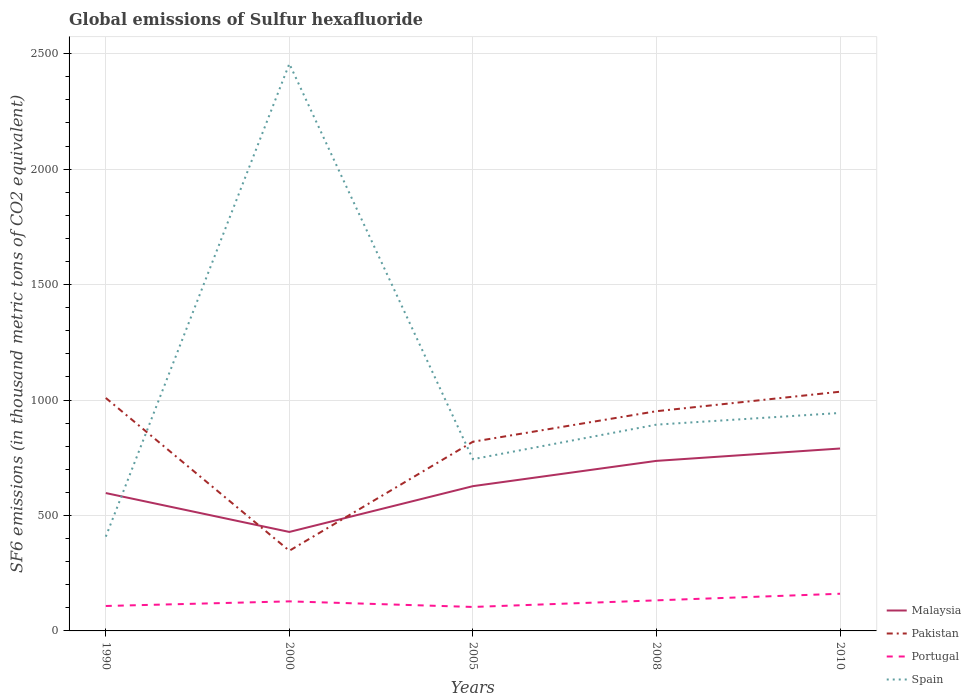How many different coloured lines are there?
Give a very brief answer. 4. Across all years, what is the maximum global emissions of Sulfur hexafluoride in Malaysia?
Your answer should be compact. 428.7. In which year was the global emissions of Sulfur hexafluoride in Spain maximum?
Your response must be concise. 1990. What is the total global emissions of Sulfur hexafluoride in Malaysia in the graph?
Your response must be concise. -139.4. What is the difference between the highest and the second highest global emissions of Sulfur hexafluoride in Portugal?
Keep it short and to the point. 57.2. Is the global emissions of Sulfur hexafluoride in Malaysia strictly greater than the global emissions of Sulfur hexafluoride in Spain over the years?
Provide a short and direct response. No. How many lines are there?
Your response must be concise. 4. How many years are there in the graph?
Make the answer very short. 5. Are the values on the major ticks of Y-axis written in scientific E-notation?
Give a very brief answer. No. Does the graph contain any zero values?
Your answer should be compact. No. How many legend labels are there?
Offer a terse response. 4. What is the title of the graph?
Offer a terse response. Global emissions of Sulfur hexafluoride. What is the label or title of the Y-axis?
Make the answer very short. SF6 emissions (in thousand metric tons of CO2 equivalent). What is the SF6 emissions (in thousand metric tons of CO2 equivalent) of Malaysia in 1990?
Your response must be concise. 597.1. What is the SF6 emissions (in thousand metric tons of CO2 equivalent) in Pakistan in 1990?
Make the answer very short. 1009. What is the SF6 emissions (in thousand metric tons of CO2 equivalent) of Portugal in 1990?
Your answer should be compact. 108. What is the SF6 emissions (in thousand metric tons of CO2 equivalent) in Spain in 1990?
Your answer should be very brief. 408.3. What is the SF6 emissions (in thousand metric tons of CO2 equivalent) in Malaysia in 2000?
Make the answer very short. 428.7. What is the SF6 emissions (in thousand metric tons of CO2 equivalent) in Pakistan in 2000?
Offer a very short reply. 347.2. What is the SF6 emissions (in thousand metric tons of CO2 equivalent) of Portugal in 2000?
Provide a succinct answer. 128. What is the SF6 emissions (in thousand metric tons of CO2 equivalent) in Spain in 2000?
Make the answer very short. 2456.5. What is the SF6 emissions (in thousand metric tons of CO2 equivalent) of Malaysia in 2005?
Make the answer very short. 627. What is the SF6 emissions (in thousand metric tons of CO2 equivalent) of Pakistan in 2005?
Offer a very short reply. 819.4. What is the SF6 emissions (in thousand metric tons of CO2 equivalent) in Portugal in 2005?
Provide a short and direct response. 103.8. What is the SF6 emissions (in thousand metric tons of CO2 equivalent) in Spain in 2005?
Provide a short and direct response. 743.8. What is the SF6 emissions (in thousand metric tons of CO2 equivalent) of Malaysia in 2008?
Ensure brevity in your answer.  736.5. What is the SF6 emissions (in thousand metric tons of CO2 equivalent) in Pakistan in 2008?
Provide a short and direct response. 951.6. What is the SF6 emissions (in thousand metric tons of CO2 equivalent) in Portugal in 2008?
Your answer should be compact. 132.4. What is the SF6 emissions (in thousand metric tons of CO2 equivalent) of Spain in 2008?
Offer a terse response. 893.4. What is the SF6 emissions (in thousand metric tons of CO2 equivalent) in Malaysia in 2010?
Your answer should be very brief. 790. What is the SF6 emissions (in thousand metric tons of CO2 equivalent) in Pakistan in 2010?
Ensure brevity in your answer.  1036. What is the SF6 emissions (in thousand metric tons of CO2 equivalent) in Portugal in 2010?
Ensure brevity in your answer.  161. What is the SF6 emissions (in thousand metric tons of CO2 equivalent) in Spain in 2010?
Your answer should be very brief. 944. Across all years, what is the maximum SF6 emissions (in thousand metric tons of CO2 equivalent) in Malaysia?
Make the answer very short. 790. Across all years, what is the maximum SF6 emissions (in thousand metric tons of CO2 equivalent) of Pakistan?
Give a very brief answer. 1036. Across all years, what is the maximum SF6 emissions (in thousand metric tons of CO2 equivalent) of Portugal?
Your response must be concise. 161. Across all years, what is the maximum SF6 emissions (in thousand metric tons of CO2 equivalent) in Spain?
Ensure brevity in your answer.  2456.5. Across all years, what is the minimum SF6 emissions (in thousand metric tons of CO2 equivalent) in Malaysia?
Offer a terse response. 428.7. Across all years, what is the minimum SF6 emissions (in thousand metric tons of CO2 equivalent) in Pakistan?
Provide a short and direct response. 347.2. Across all years, what is the minimum SF6 emissions (in thousand metric tons of CO2 equivalent) in Portugal?
Give a very brief answer. 103.8. Across all years, what is the minimum SF6 emissions (in thousand metric tons of CO2 equivalent) of Spain?
Your response must be concise. 408.3. What is the total SF6 emissions (in thousand metric tons of CO2 equivalent) of Malaysia in the graph?
Ensure brevity in your answer.  3179.3. What is the total SF6 emissions (in thousand metric tons of CO2 equivalent) in Pakistan in the graph?
Ensure brevity in your answer.  4163.2. What is the total SF6 emissions (in thousand metric tons of CO2 equivalent) of Portugal in the graph?
Keep it short and to the point. 633.2. What is the total SF6 emissions (in thousand metric tons of CO2 equivalent) of Spain in the graph?
Offer a very short reply. 5446. What is the difference between the SF6 emissions (in thousand metric tons of CO2 equivalent) of Malaysia in 1990 and that in 2000?
Ensure brevity in your answer.  168.4. What is the difference between the SF6 emissions (in thousand metric tons of CO2 equivalent) of Pakistan in 1990 and that in 2000?
Your answer should be very brief. 661.8. What is the difference between the SF6 emissions (in thousand metric tons of CO2 equivalent) of Spain in 1990 and that in 2000?
Your answer should be very brief. -2048.2. What is the difference between the SF6 emissions (in thousand metric tons of CO2 equivalent) in Malaysia in 1990 and that in 2005?
Provide a short and direct response. -29.9. What is the difference between the SF6 emissions (in thousand metric tons of CO2 equivalent) of Pakistan in 1990 and that in 2005?
Make the answer very short. 189.6. What is the difference between the SF6 emissions (in thousand metric tons of CO2 equivalent) of Spain in 1990 and that in 2005?
Provide a succinct answer. -335.5. What is the difference between the SF6 emissions (in thousand metric tons of CO2 equivalent) of Malaysia in 1990 and that in 2008?
Offer a very short reply. -139.4. What is the difference between the SF6 emissions (in thousand metric tons of CO2 equivalent) in Pakistan in 1990 and that in 2008?
Offer a terse response. 57.4. What is the difference between the SF6 emissions (in thousand metric tons of CO2 equivalent) in Portugal in 1990 and that in 2008?
Ensure brevity in your answer.  -24.4. What is the difference between the SF6 emissions (in thousand metric tons of CO2 equivalent) of Spain in 1990 and that in 2008?
Your answer should be very brief. -485.1. What is the difference between the SF6 emissions (in thousand metric tons of CO2 equivalent) in Malaysia in 1990 and that in 2010?
Provide a short and direct response. -192.9. What is the difference between the SF6 emissions (in thousand metric tons of CO2 equivalent) of Pakistan in 1990 and that in 2010?
Provide a short and direct response. -27. What is the difference between the SF6 emissions (in thousand metric tons of CO2 equivalent) in Portugal in 1990 and that in 2010?
Ensure brevity in your answer.  -53. What is the difference between the SF6 emissions (in thousand metric tons of CO2 equivalent) in Spain in 1990 and that in 2010?
Your answer should be compact. -535.7. What is the difference between the SF6 emissions (in thousand metric tons of CO2 equivalent) in Malaysia in 2000 and that in 2005?
Make the answer very short. -198.3. What is the difference between the SF6 emissions (in thousand metric tons of CO2 equivalent) of Pakistan in 2000 and that in 2005?
Offer a very short reply. -472.2. What is the difference between the SF6 emissions (in thousand metric tons of CO2 equivalent) of Portugal in 2000 and that in 2005?
Provide a short and direct response. 24.2. What is the difference between the SF6 emissions (in thousand metric tons of CO2 equivalent) in Spain in 2000 and that in 2005?
Offer a terse response. 1712.7. What is the difference between the SF6 emissions (in thousand metric tons of CO2 equivalent) in Malaysia in 2000 and that in 2008?
Offer a terse response. -307.8. What is the difference between the SF6 emissions (in thousand metric tons of CO2 equivalent) of Pakistan in 2000 and that in 2008?
Offer a very short reply. -604.4. What is the difference between the SF6 emissions (in thousand metric tons of CO2 equivalent) in Portugal in 2000 and that in 2008?
Provide a short and direct response. -4.4. What is the difference between the SF6 emissions (in thousand metric tons of CO2 equivalent) in Spain in 2000 and that in 2008?
Offer a very short reply. 1563.1. What is the difference between the SF6 emissions (in thousand metric tons of CO2 equivalent) in Malaysia in 2000 and that in 2010?
Offer a terse response. -361.3. What is the difference between the SF6 emissions (in thousand metric tons of CO2 equivalent) in Pakistan in 2000 and that in 2010?
Give a very brief answer. -688.8. What is the difference between the SF6 emissions (in thousand metric tons of CO2 equivalent) of Portugal in 2000 and that in 2010?
Make the answer very short. -33. What is the difference between the SF6 emissions (in thousand metric tons of CO2 equivalent) in Spain in 2000 and that in 2010?
Your answer should be compact. 1512.5. What is the difference between the SF6 emissions (in thousand metric tons of CO2 equivalent) in Malaysia in 2005 and that in 2008?
Your answer should be very brief. -109.5. What is the difference between the SF6 emissions (in thousand metric tons of CO2 equivalent) in Pakistan in 2005 and that in 2008?
Your answer should be very brief. -132.2. What is the difference between the SF6 emissions (in thousand metric tons of CO2 equivalent) of Portugal in 2005 and that in 2008?
Make the answer very short. -28.6. What is the difference between the SF6 emissions (in thousand metric tons of CO2 equivalent) of Spain in 2005 and that in 2008?
Ensure brevity in your answer.  -149.6. What is the difference between the SF6 emissions (in thousand metric tons of CO2 equivalent) in Malaysia in 2005 and that in 2010?
Your answer should be very brief. -163. What is the difference between the SF6 emissions (in thousand metric tons of CO2 equivalent) in Pakistan in 2005 and that in 2010?
Keep it short and to the point. -216.6. What is the difference between the SF6 emissions (in thousand metric tons of CO2 equivalent) of Portugal in 2005 and that in 2010?
Your answer should be very brief. -57.2. What is the difference between the SF6 emissions (in thousand metric tons of CO2 equivalent) in Spain in 2005 and that in 2010?
Your answer should be very brief. -200.2. What is the difference between the SF6 emissions (in thousand metric tons of CO2 equivalent) of Malaysia in 2008 and that in 2010?
Your answer should be very brief. -53.5. What is the difference between the SF6 emissions (in thousand metric tons of CO2 equivalent) in Pakistan in 2008 and that in 2010?
Provide a succinct answer. -84.4. What is the difference between the SF6 emissions (in thousand metric tons of CO2 equivalent) in Portugal in 2008 and that in 2010?
Your answer should be very brief. -28.6. What is the difference between the SF6 emissions (in thousand metric tons of CO2 equivalent) in Spain in 2008 and that in 2010?
Your response must be concise. -50.6. What is the difference between the SF6 emissions (in thousand metric tons of CO2 equivalent) of Malaysia in 1990 and the SF6 emissions (in thousand metric tons of CO2 equivalent) of Pakistan in 2000?
Provide a short and direct response. 249.9. What is the difference between the SF6 emissions (in thousand metric tons of CO2 equivalent) of Malaysia in 1990 and the SF6 emissions (in thousand metric tons of CO2 equivalent) of Portugal in 2000?
Offer a terse response. 469.1. What is the difference between the SF6 emissions (in thousand metric tons of CO2 equivalent) in Malaysia in 1990 and the SF6 emissions (in thousand metric tons of CO2 equivalent) in Spain in 2000?
Your answer should be very brief. -1859.4. What is the difference between the SF6 emissions (in thousand metric tons of CO2 equivalent) of Pakistan in 1990 and the SF6 emissions (in thousand metric tons of CO2 equivalent) of Portugal in 2000?
Your answer should be compact. 881. What is the difference between the SF6 emissions (in thousand metric tons of CO2 equivalent) of Pakistan in 1990 and the SF6 emissions (in thousand metric tons of CO2 equivalent) of Spain in 2000?
Provide a short and direct response. -1447.5. What is the difference between the SF6 emissions (in thousand metric tons of CO2 equivalent) in Portugal in 1990 and the SF6 emissions (in thousand metric tons of CO2 equivalent) in Spain in 2000?
Ensure brevity in your answer.  -2348.5. What is the difference between the SF6 emissions (in thousand metric tons of CO2 equivalent) of Malaysia in 1990 and the SF6 emissions (in thousand metric tons of CO2 equivalent) of Pakistan in 2005?
Your answer should be very brief. -222.3. What is the difference between the SF6 emissions (in thousand metric tons of CO2 equivalent) in Malaysia in 1990 and the SF6 emissions (in thousand metric tons of CO2 equivalent) in Portugal in 2005?
Provide a succinct answer. 493.3. What is the difference between the SF6 emissions (in thousand metric tons of CO2 equivalent) in Malaysia in 1990 and the SF6 emissions (in thousand metric tons of CO2 equivalent) in Spain in 2005?
Keep it short and to the point. -146.7. What is the difference between the SF6 emissions (in thousand metric tons of CO2 equivalent) of Pakistan in 1990 and the SF6 emissions (in thousand metric tons of CO2 equivalent) of Portugal in 2005?
Your answer should be very brief. 905.2. What is the difference between the SF6 emissions (in thousand metric tons of CO2 equivalent) in Pakistan in 1990 and the SF6 emissions (in thousand metric tons of CO2 equivalent) in Spain in 2005?
Make the answer very short. 265.2. What is the difference between the SF6 emissions (in thousand metric tons of CO2 equivalent) in Portugal in 1990 and the SF6 emissions (in thousand metric tons of CO2 equivalent) in Spain in 2005?
Offer a very short reply. -635.8. What is the difference between the SF6 emissions (in thousand metric tons of CO2 equivalent) of Malaysia in 1990 and the SF6 emissions (in thousand metric tons of CO2 equivalent) of Pakistan in 2008?
Your response must be concise. -354.5. What is the difference between the SF6 emissions (in thousand metric tons of CO2 equivalent) in Malaysia in 1990 and the SF6 emissions (in thousand metric tons of CO2 equivalent) in Portugal in 2008?
Your answer should be very brief. 464.7. What is the difference between the SF6 emissions (in thousand metric tons of CO2 equivalent) in Malaysia in 1990 and the SF6 emissions (in thousand metric tons of CO2 equivalent) in Spain in 2008?
Your answer should be compact. -296.3. What is the difference between the SF6 emissions (in thousand metric tons of CO2 equivalent) of Pakistan in 1990 and the SF6 emissions (in thousand metric tons of CO2 equivalent) of Portugal in 2008?
Keep it short and to the point. 876.6. What is the difference between the SF6 emissions (in thousand metric tons of CO2 equivalent) of Pakistan in 1990 and the SF6 emissions (in thousand metric tons of CO2 equivalent) of Spain in 2008?
Make the answer very short. 115.6. What is the difference between the SF6 emissions (in thousand metric tons of CO2 equivalent) in Portugal in 1990 and the SF6 emissions (in thousand metric tons of CO2 equivalent) in Spain in 2008?
Ensure brevity in your answer.  -785.4. What is the difference between the SF6 emissions (in thousand metric tons of CO2 equivalent) in Malaysia in 1990 and the SF6 emissions (in thousand metric tons of CO2 equivalent) in Pakistan in 2010?
Ensure brevity in your answer.  -438.9. What is the difference between the SF6 emissions (in thousand metric tons of CO2 equivalent) of Malaysia in 1990 and the SF6 emissions (in thousand metric tons of CO2 equivalent) of Portugal in 2010?
Ensure brevity in your answer.  436.1. What is the difference between the SF6 emissions (in thousand metric tons of CO2 equivalent) of Malaysia in 1990 and the SF6 emissions (in thousand metric tons of CO2 equivalent) of Spain in 2010?
Your answer should be very brief. -346.9. What is the difference between the SF6 emissions (in thousand metric tons of CO2 equivalent) of Pakistan in 1990 and the SF6 emissions (in thousand metric tons of CO2 equivalent) of Portugal in 2010?
Give a very brief answer. 848. What is the difference between the SF6 emissions (in thousand metric tons of CO2 equivalent) of Pakistan in 1990 and the SF6 emissions (in thousand metric tons of CO2 equivalent) of Spain in 2010?
Offer a terse response. 65. What is the difference between the SF6 emissions (in thousand metric tons of CO2 equivalent) of Portugal in 1990 and the SF6 emissions (in thousand metric tons of CO2 equivalent) of Spain in 2010?
Your answer should be compact. -836. What is the difference between the SF6 emissions (in thousand metric tons of CO2 equivalent) in Malaysia in 2000 and the SF6 emissions (in thousand metric tons of CO2 equivalent) in Pakistan in 2005?
Make the answer very short. -390.7. What is the difference between the SF6 emissions (in thousand metric tons of CO2 equivalent) in Malaysia in 2000 and the SF6 emissions (in thousand metric tons of CO2 equivalent) in Portugal in 2005?
Ensure brevity in your answer.  324.9. What is the difference between the SF6 emissions (in thousand metric tons of CO2 equivalent) in Malaysia in 2000 and the SF6 emissions (in thousand metric tons of CO2 equivalent) in Spain in 2005?
Keep it short and to the point. -315.1. What is the difference between the SF6 emissions (in thousand metric tons of CO2 equivalent) of Pakistan in 2000 and the SF6 emissions (in thousand metric tons of CO2 equivalent) of Portugal in 2005?
Provide a succinct answer. 243.4. What is the difference between the SF6 emissions (in thousand metric tons of CO2 equivalent) of Pakistan in 2000 and the SF6 emissions (in thousand metric tons of CO2 equivalent) of Spain in 2005?
Your answer should be very brief. -396.6. What is the difference between the SF6 emissions (in thousand metric tons of CO2 equivalent) in Portugal in 2000 and the SF6 emissions (in thousand metric tons of CO2 equivalent) in Spain in 2005?
Your response must be concise. -615.8. What is the difference between the SF6 emissions (in thousand metric tons of CO2 equivalent) of Malaysia in 2000 and the SF6 emissions (in thousand metric tons of CO2 equivalent) of Pakistan in 2008?
Make the answer very short. -522.9. What is the difference between the SF6 emissions (in thousand metric tons of CO2 equivalent) of Malaysia in 2000 and the SF6 emissions (in thousand metric tons of CO2 equivalent) of Portugal in 2008?
Give a very brief answer. 296.3. What is the difference between the SF6 emissions (in thousand metric tons of CO2 equivalent) of Malaysia in 2000 and the SF6 emissions (in thousand metric tons of CO2 equivalent) of Spain in 2008?
Your answer should be compact. -464.7. What is the difference between the SF6 emissions (in thousand metric tons of CO2 equivalent) in Pakistan in 2000 and the SF6 emissions (in thousand metric tons of CO2 equivalent) in Portugal in 2008?
Offer a terse response. 214.8. What is the difference between the SF6 emissions (in thousand metric tons of CO2 equivalent) in Pakistan in 2000 and the SF6 emissions (in thousand metric tons of CO2 equivalent) in Spain in 2008?
Your response must be concise. -546.2. What is the difference between the SF6 emissions (in thousand metric tons of CO2 equivalent) in Portugal in 2000 and the SF6 emissions (in thousand metric tons of CO2 equivalent) in Spain in 2008?
Your response must be concise. -765.4. What is the difference between the SF6 emissions (in thousand metric tons of CO2 equivalent) of Malaysia in 2000 and the SF6 emissions (in thousand metric tons of CO2 equivalent) of Pakistan in 2010?
Offer a very short reply. -607.3. What is the difference between the SF6 emissions (in thousand metric tons of CO2 equivalent) in Malaysia in 2000 and the SF6 emissions (in thousand metric tons of CO2 equivalent) in Portugal in 2010?
Offer a terse response. 267.7. What is the difference between the SF6 emissions (in thousand metric tons of CO2 equivalent) of Malaysia in 2000 and the SF6 emissions (in thousand metric tons of CO2 equivalent) of Spain in 2010?
Provide a short and direct response. -515.3. What is the difference between the SF6 emissions (in thousand metric tons of CO2 equivalent) of Pakistan in 2000 and the SF6 emissions (in thousand metric tons of CO2 equivalent) of Portugal in 2010?
Ensure brevity in your answer.  186.2. What is the difference between the SF6 emissions (in thousand metric tons of CO2 equivalent) in Pakistan in 2000 and the SF6 emissions (in thousand metric tons of CO2 equivalent) in Spain in 2010?
Provide a succinct answer. -596.8. What is the difference between the SF6 emissions (in thousand metric tons of CO2 equivalent) in Portugal in 2000 and the SF6 emissions (in thousand metric tons of CO2 equivalent) in Spain in 2010?
Your answer should be compact. -816. What is the difference between the SF6 emissions (in thousand metric tons of CO2 equivalent) of Malaysia in 2005 and the SF6 emissions (in thousand metric tons of CO2 equivalent) of Pakistan in 2008?
Make the answer very short. -324.6. What is the difference between the SF6 emissions (in thousand metric tons of CO2 equivalent) of Malaysia in 2005 and the SF6 emissions (in thousand metric tons of CO2 equivalent) of Portugal in 2008?
Your answer should be very brief. 494.6. What is the difference between the SF6 emissions (in thousand metric tons of CO2 equivalent) in Malaysia in 2005 and the SF6 emissions (in thousand metric tons of CO2 equivalent) in Spain in 2008?
Provide a succinct answer. -266.4. What is the difference between the SF6 emissions (in thousand metric tons of CO2 equivalent) of Pakistan in 2005 and the SF6 emissions (in thousand metric tons of CO2 equivalent) of Portugal in 2008?
Offer a terse response. 687. What is the difference between the SF6 emissions (in thousand metric tons of CO2 equivalent) in Pakistan in 2005 and the SF6 emissions (in thousand metric tons of CO2 equivalent) in Spain in 2008?
Give a very brief answer. -74. What is the difference between the SF6 emissions (in thousand metric tons of CO2 equivalent) of Portugal in 2005 and the SF6 emissions (in thousand metric tons of CO2 equivalent) of Spain in 2008?
Provide a succinct answer. -789.6. What is the difference between the SF6 emissions (in thousand metric tons of CO2 equivalent) of Malaysia in 2005 and the SF6 emissions (in thousand metric tons of CO2 equivalent) of Pakistan in 2010?
Offer a terse response. -409. What is the difference between the SF6 emissions (in thousand metric tons of CO2 equivalent) of Malaysia in 2005 and the SF6 emissions (in thousand metric tons of CO2 equivalent) of Portugal in 2010?
Offer a very short reply. 466. What is the difference between the SF6 emissions (in thousand metric tons of CO2 equivalent) in Malaysia in 2005 and the SF6 emissions (in thousand metric tons of CO2 equivalent) in Spain in 2010?
Make the answer very short. -317. What is the difference between the SF6 emissions (in thousand metric tons of CO2 equivalent) in Pakistan in 2005 and the SF6 emissions (in thousand metric tons of CO2 equivalent) in Portugal in 2010?
Your answer should be very brief. 658.4. What is the difference between the SF6 emissions (in thousand metric tons of CO2 equivalent) of Pakistan in 2005 and the SF6 emissions (in thousand metric tons of CO2 equivalent) of Spain in 2010?
Offer a very short reply. -124.6. What is the difference between the SF6 emissions (in thousand metric tons of CO2 equivalent) in Portugal in 2005 and the SF6 emissions (in thousand metric tons of CO2 equivalent) in Spain in 2010?
Your response must be concise. -840.2. What is the difference between the SF6 emissions (in thousand metric tons of CO2 equivalent) in Malaysia in 2008 and the SF6 emissions (in thousand metric tons of CO2 equivalent) in Pakistan in 2010?
Your answer should be very brief. -299.5. What is the difference between the SF6 emissions (in thousand metric tons of CO2 equivalent) in Malaysia in 2008 and the SF6 emissions (in thousand metric tons of CO2 equivalent) in Portugal in 2010?
Make the answer very short. 575.5. What is the difference between the SF6 emissions (in thousand metric tons of CO2 equivalent) in Malaysia in 2008 and the SF6 emissions (in thousand metric tons of CO2 equivalent) in Spain in 2010?
Ensure brevity in your answer.  -207.5. What is the difference between the SF6 emissions (in thousand metric tons of CO2 equivalent) in Pakistan in 2008 and the SF6 emissions (in thousand metric tons of CO2 equivalent) in Portugal in 2010?
Keep it short and to the point. 790.6. What is the difference between the SF6 emissions (in thousand metric tons of CO2 equivalent) in Pakistan in 2008 and the SF6 emissions (in thousand metric tons of CO2 equivalent) in Spain in 2010?
Give a very brief answer. 7.6. What is the difference between the SF6 emissions (in thousand metric tons of CO2 equivalent) of Portugal in 2008 and the SF6 emissions (in thousand metric tons of CO2 equivalent) of Spain in 2010?
Offer a very short reply. -811.6. What is the average SF6 emissions (in thousand metric tons of CO2 equivalent) in Malaysia per year?
Give a very brief answer. 635.86. What is the average SF6 emissions (in thousand metric tons of CO2 equivalent) in Pakistan per year?
Provide a short and direct response. 832.64. What is the average SF6 emissions (in thousand metric tons of CO2 equivalent) of Portugal per year?
Provide a short and direct response. 126.64. What is the average SF6 emissions (in thousand metric tons of CO2 equivalent) in Spain per year?
Your response must be concise. 1089.2. In the year 1990, what is the difference between the SF6 emissions (in thousand metric tons of CO2 equivalent) of Malaysia and SF6 emissions (in thousand metric tons of CO2 equivalent) of Pakistan?
Give a very brief answer. -411.9. In the year 1990, what is the difference between the SF6 emissions (in thousand metric tons of CO2 equivalent) of Malaysia and SF6 emissions (in thousand metric tons of CO2 equivalent) of Portugal?
Keep it short and to the point. 489.1. In the year 1990, what is the difference between the SF6 emissions (in thousand metric tons of CO2 equivalent) of Malaysia and SF6 emissions (in thousand metric tons of CO2 equivalent) of Spain?
Provide a short and direct response. 188.8. In the year 1990, what is the difference between the SF6 emissions (in thousand metric tons of CO2 equivalent) in Pakistan and SF6 emissions (in thousand metric tons of CO2 equivalent) in Portugal?
Provide a succinct answer. 901. In the year 1990, what is the difference between the SF6 emissions (in thousand metric tons of CO2 equivalent) in Pakistan and SF6 emissions (in thousand metric tons of CO2 equivalent) in Spain?
Offer a very short reply. 600.7. In the year 1990, what is the difference between the SF6 emissions (in thousand metric tons of CO2 equivalent) of Portugal and SF6 emissions (in thousand metric tons of CO2 equivalent) of Spain?
Your answer should be very brief. -300.3. In the year 2000, what is the difference between the SF6 emissions (in thousand metric tons of CO2 equivalent) of Malaysia and SF6 emissions (in thousand metric tons of CO2 equivalent) of Pakistan?
Offer a terse response. 81.5. In the year 2000, what is the difference between the SF6 emissions (in thousand metric tons of CO2 equivalent) in Malaysia and SF6 emissions (in thousand metric tons of CO2 equivalent) in Portugal?
Offer a very short reply. 300.7. In the year 2000, what is the difference between the SF6 emissions (in thousand metric tons of CO2 equivalent) of Malaysia and SF6 emissions (in thousand metric tons of CO2 equivalent) of Spain?
Your response must be concise. -2027.8. In the year 2000, what is the difference between the SF6 emissions (in thousand metric tons of CO2 equivalent) of Pakistan and SF6 emissions (in thousand metric tons of CO2 equivalent) of Portugal?
Ensure brevity in your answer.  219.2. In the year 2000, what is the difference between the SF6 emissions (in thousand metric tons of CO2 equivalent) of Pakistan and SF6 emissions (in thousand metric tons of CO2 equivalent) of Spain?
Offer a terse response. -2109.3. In the year 2000, what is the difference between the SF6 emissions (in thousand metric tons of CO2 equivalent) of Portugal and SF6 emissions (in thousand metric tons of CO2 equivalent) of Spain?
Provide a short and direct response. -2328.5. In the year 2005, what is the difference between the SF6 emissions (in thousand metric tons of CO2 equivalent) in Malaysia and SF6 emissions (in thousand metric tons of CO2 equivalent) in Pakistan?
Your answer should be compact. -192.4. In the year 2005, what is the difference between the SF6 emissions (in thousand metric tons of CO2 equivalent) of Malaysia and SF6 emissions (in thousand metric tons of CO2 equivalent) of Portugal?
Keep it short and to the point. 523.2. In the year 2005, what is the difference between the SF6 emissions (in thousand metric tons of CO2 equivalent) of Malaysia and SF6 emissions (in thousand metric tons of CO2 equivalent) of Spain?
Your answer should be compact. -116.8. In the year 2005, what is the difference between the SF6 emissions (in thousand metric tons of CO2 equivalent) in Pakistan and SF6 emissions (in thousand metric tons of CO2 equivalent) in Portugal?
Offer a very short reply. 715.6. In the year 2005, what is the difference between the SF6 emissions (in thousand metric tons of CO2 equivalent) in Pakistan and SF6 emissions (in thousand metric tons of CO2 equivalent) in Spain?
Provide a short and direct response. 75.6. In the year 2005, what is the difference between the SF6 emissions (in thousand metric tons of CO2 equivalent) in Portugal and SF6 emissions (in thousand metric tons of CO2 equivalent) in Spain?
Provide a succinct answer. -640. In the year 2008, what is the difference between the SF6 emissions (in thousand metric tons of CO2 equivalent) of Malaysia and SF6 emissions (in thousand metric tons of CO2 equivalent) of Pakistan?
Offer a terse response. -215.1. In the year 2008, what is the difference between the SF6 emissions (in thousand metric tons of CO2 equivalent) of Malaysia and SF6 emissions (in thousand metric tons of CO2 equivalent) of Portugal?
Your response must be concise. 604.1. In the year 2008, what is the difference between the SF6 emissions (in thousand metric tons of CO2 equivalent) in Malaysia and SF6 emissions (in thousand metric tons of CO2 equivalent) in Spain?
Give a very brief answer. -156.9. In the year 2008, what is the difference between the SF6 emissions (in thousand metric tons of CO2 equivalent) in Pakistan and SF6 emissions (in thousand metric tons of CO2 equivalent) in Portugal?
Keep it short and to the point. 819.2. In the year 2008, what is the difference between the SF6 emissions (in thousand metric tons of CO2 equivalent) in Pakistan and SF6 emissions (in thousand metric tons of CO2 equivalent) in Spain?
Keep it short and to the point. 58.2. In the year 2008, what is the difference between the SF6 emissions (in thousand metric tons of CO2 equivalent) of Portugal and SF6 emissions (in thousand metric tons of CO2 equivalent) of Spain?
Provide a short and direct response. -761. In the year 2010, what is the difference between the SF6 emissions (in thousand metric tons of CO2 equivalent) in Malaysia and SF6 emissions (in thousand metric tons of CO2 equivalent) in Pakistan?
Your response must be concise. -246. In the year 2010, what is the difference between the SF6 emissions (in thousand metric tons of CO2 equivalent) of Malaysia and SF6 emissions (in thousand metric tons of CO2 equivalent) of Portugal?
Give a very brief answer. 629. In the year 2010, what is the difference between the SF6 emissions (in thousand metric tons of CO2 equivalent) of Malaysia and SF6 emissions (in thousand metric tons of CO2 equivalent) of Spain?
Make the answer very short. -154. In the year 2010, what is the difference between the SF6 emissions (in thousand metric tons of CO2 equivalent) in Pakistan and SF6 emissions (in thousand metric tons of CO2 equivalent) in Portugal?
Provide a short and direct response. 875. In the year 2010, what is the difference between the SF6 emissions (in thousand metric tons of CO2 equivalent) in Pakistan and SF6 emissions (in thousand metric tons of CO2 equivalent) in Spain?
Your response must be concise. 92. In the year 2010, what is the difference between the SF6 emissions (in thousand metric tons of CO2 equivalent) of Portugal and SF6 emissions (in thousand metric tons of CO2 equivalent) of Spain?
Offer a very short reply. -783. What is the ratio of the SF6 emissions (in thousand metric tons of CO2 equivalent) of Malaysia in 1990 to that in 2000?
Offer a very short reply. 1.39. What is the ratio of the SF6 emissions (in thousand metric tons of CO2 equivalent) of Pakistan in 1990 to that in 2000?
Provide a succinct answer. 2.91. What is the ratio of the SF6 emissions (in thousand metric tons of CO2 equivalent) of Portugal in 1990 to that in 2000?
Ensure brevity in your answer.  0.84. What is the ratio of the SF6 emissions (in thousand metric tons of CO2 equivalent) of Spain in 1990 to that in 2000?
Ensure brevity in your answer.  0.17. What is the ratio of the SF6 emissions (in thousand metric tons of CO2 equivalent) in Malaysia in 1990 to that in 2005?
Your answer should be compact. 0.95. What is the ratio of the SF6 emissions (in thousand metric tons of CO2 equivalent) in Pakistan in 1990 to that in 2005?
Your answer should be compact. 1.23. What is the ratio of the SF6 emissions (in thousand metric tons of CO2 equivalent) of Portugal in 1990 to that in 2005?
Give a very brief answer. 1.04. What is the ratio of the SF6 emissions (in thousand metric tons of CO2 equivalent) of Spain in 1990 to that in 2005?
Give a very brief answer. 0.55. What is the ratio of the SF6 emissions (in thousand metric tons of CO2 equivalent) in Malaysia in 1990 to that in 2008?
Offer a terse response. 0.81. What is the ratio of the SF6 emissions (in thousand metric tons of CO2 equivalent) in Pakistan in 1990 to that in 2008?
Provide a succinct answer. 1.06. What is the ratio of the SF6 emissions (in thousand metric tons of CO2 equivalent) in Portugal in 1990 to that in 2008?
Provide a succinct answer. 0.82. What is the ratio of the SF6 emissions (in thousand metric tons of CO2 equivalent) of Spain in 1990 to that in 2008?
Your answer should be very brief. 0.46. What is the ratio of the SF6 emissions (in thousand metric tons of CO2 equivalent) of Malaysia in 1990 to that in 2010?
Your answer should be compact. 0.76. What is the ratio of the SF6 emissions (in thousand metric tons of CO2 equivalent) in Pakistan in 1990 to that in 2010?
Keep it short and to the point. 0.97. What is the ratio of the SF6 emissions (in thousand metric tons of CO2 equivalent) of Portugal in 1990 to that in 2010?
Offer a terse response. 0.67. What is the ratio of the SF6 emissions (in thousand metric tons of CO2 equivalent) of Spain in 1990 to that in 2010?
Ensure brevity in your answer.  0.43. What is the ratio of the SF6 emissions (in thousand metric tons of CO2 equivalent) of Malaysia in 2000 to that in 2005?
Your answer should be very brief. 0.68. What is the ratio of the SF6 emissions (in thousand metric tons of CO2 equivalent) of Pakistan in 2000 to that in 2005?
Give a very brief answer. 0.42. What is the ratio of the SF6 emissions (in thousand metric tons of CO2 equivalent) of Portugal in 2000 to that in 2005?
Make the answer very short. 1.23. What is the ratio of the SF6 emissions (in thousand metric tons of CO2 equivalent) in Spain in 2000 to that in 2005?
Your answer should be very brief. 3.3. What is the ratio of the SF6 emissions (in thousand metric tons of CO2 equivalent) of Malaysia in 2000 to that in 2008?
Your answer should be very brief. 0.58. What is the ratio of the SF6 emissions (in thousand metric tons of CO2 equivalent) of Pakistan in 2000 to that in 2008?
Your response must be concise. 0.36. What is the ratio of the SF6 emissions (in thousand metric tons of CO2 equivalent) in Portugal in 2000 to that in 2008?
Your response must be concise. 0.97. What is the ratio of the SF6 emissions (in thousand metric tons of CO2 equivalent) in Spain in 2000 to that in 2008?
Make the answer very short. 2.75. What is the ratio of the SF6 emissions (in thousand metric tons of CO2 equivalent) in Malaysia in 2000 to that in 2010?
Your response must be concise. 0.54. What is the ratio of the SF6 emissions (in thousand metric tons of CO2 equivalent) in Pakistan in 2000 to that in 2010?
Your answer should be compact. 0.34. What is the ratio of the SF6 emissions (in thousand metric tons of CO2 equivalent) in Portugal in 2000 to that in 2010?
Your answer should be very brief. 0.8. What is the ratio of the SF6 emissions (in thousand metric tons of CO2 equivalent) in Spain in 2000 to that in 2010?
Offer a terse response. 2.6. What is the ratio of the SF6 emissions (in thousand metric tons of CO2 equivalent) in Malaysia in 2005 to that in 2008?
Offer a very short reply. 0.85. What is the ratio of the SF6 emissions (in thousand metric tons of CO2 equivalent) in Pakistan in 2005 to that in 2008?
Keep it short and to the point. 0.86. What is the ratio of the SF6 emissions (in thousand metric tons of CO2 equivalent) in Portugal in 2005 to that in 2008?
Provide a short and direct response. 0.78. What is the ratio of the SF6 emissions (in thousand metric tons of CO2 equivalent) of Spain in 2005 to that in 2008?
Give a very brief answer. 0.83. What is the ratio of the SF6 emissions (in thousand metric tons of CO2 equivalent) of Malaysia in 2005 to that in 2010?
Your response must be concise. 0.79. What is the ratio of the SF6 emissions (in thousand metric tons of CO2 equivalent) in Pakistan in 2005 to that in 2010?
Offer a very short reply. 0.79. What is the ratio of the SF6 emissions (in thousand metric tons of CO2 equivalent) in Portugal in 2005 to that in 2010?
Your answer should be compact. 0.64. What is the ratio of the SF6 emissions (in thousand metric tons of CO2 equivalent) of Spain in 2005 to that in 2010?
Provide a short and direct response. 0.79. What is the ratio of the SF6 emissions (in thousand metric tons of CO2 equivalent) in Malaysia in 2008 to that in 2010?
Offer a very short reply. 0.93. What is the ratio of the SF6 emissions (in thousand metric tons of CO2 equivalent) in Pakistan in 2008 to that in 2010?
Offer a very short reply. 0.92. What is the ratio of the SF6 emissions (in thousand metric tons of CO2 equivalent) in Portugal in 2008 to that in 2010?
Your response must be concise. 0.82. What is the ratio of the SF6 emissions (in thousand metric tons of CO2 equivalent) of Spain in 2008 to that in 2010?
Provide a short and direct response. 0.95. What is the difference between the highest and the second highest SF6 emissions (in thousand metric tons of CO2 equivalent) of Malaysia?
Offer a very short reply. 53.5. What is the difference between the highest and the second highest SF6 emissions (in thousand metric tons of CO2 equivalent) of Pakistan?
Your response must be concise. 27. What is the difference between the highest and the second highest SF6 emissions (in thousand metric tons of CO2 equivalent) in Portugal?
Ensure brevity in your answer.  28.6. What is the difference between the highest and the second highest SF6 emissions (in thousand metric tons of CO2 equivalent) in Spain?
Your answer should be very brief. 1512.5. What is the difference between the highest and the lowest SF6 emissions (in thousand metric tons of CO2 equivalent) of Malaysia?
Provide a short and direct response. 361.3. What is the difference between the highest and the lowest SF6 emissions (in thousand metric tons of CO2 equivalent) of Pakistan?
Offer a terse response. 688.8. What is the difference between the highest and the lowest SF6 emissions (in thousand metric tons of CO2 equivalent) of Portugal?
Provide a succinct answer. 57.2. What is the difference between the highest and the lowest SF6 emissions (in thousand metric tons of CO2 equivalent) of Spain?
Your answer should be very brief. 2048.2. 